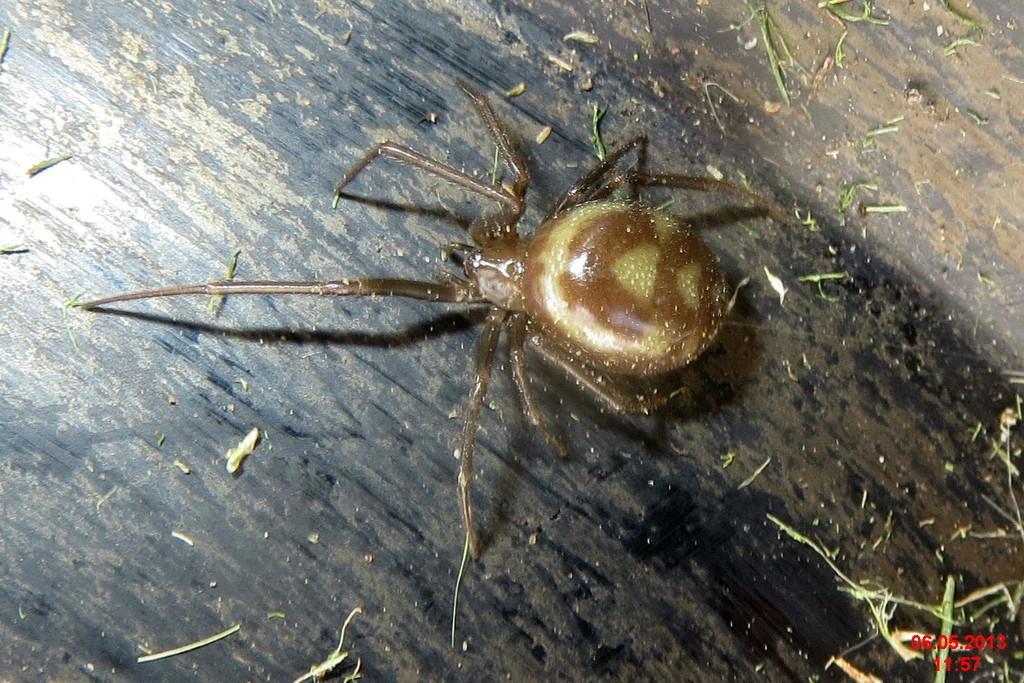Describe this image in one or two sentences. In this image I can see an insect which is in dark brown color. It is on the black color surface. 